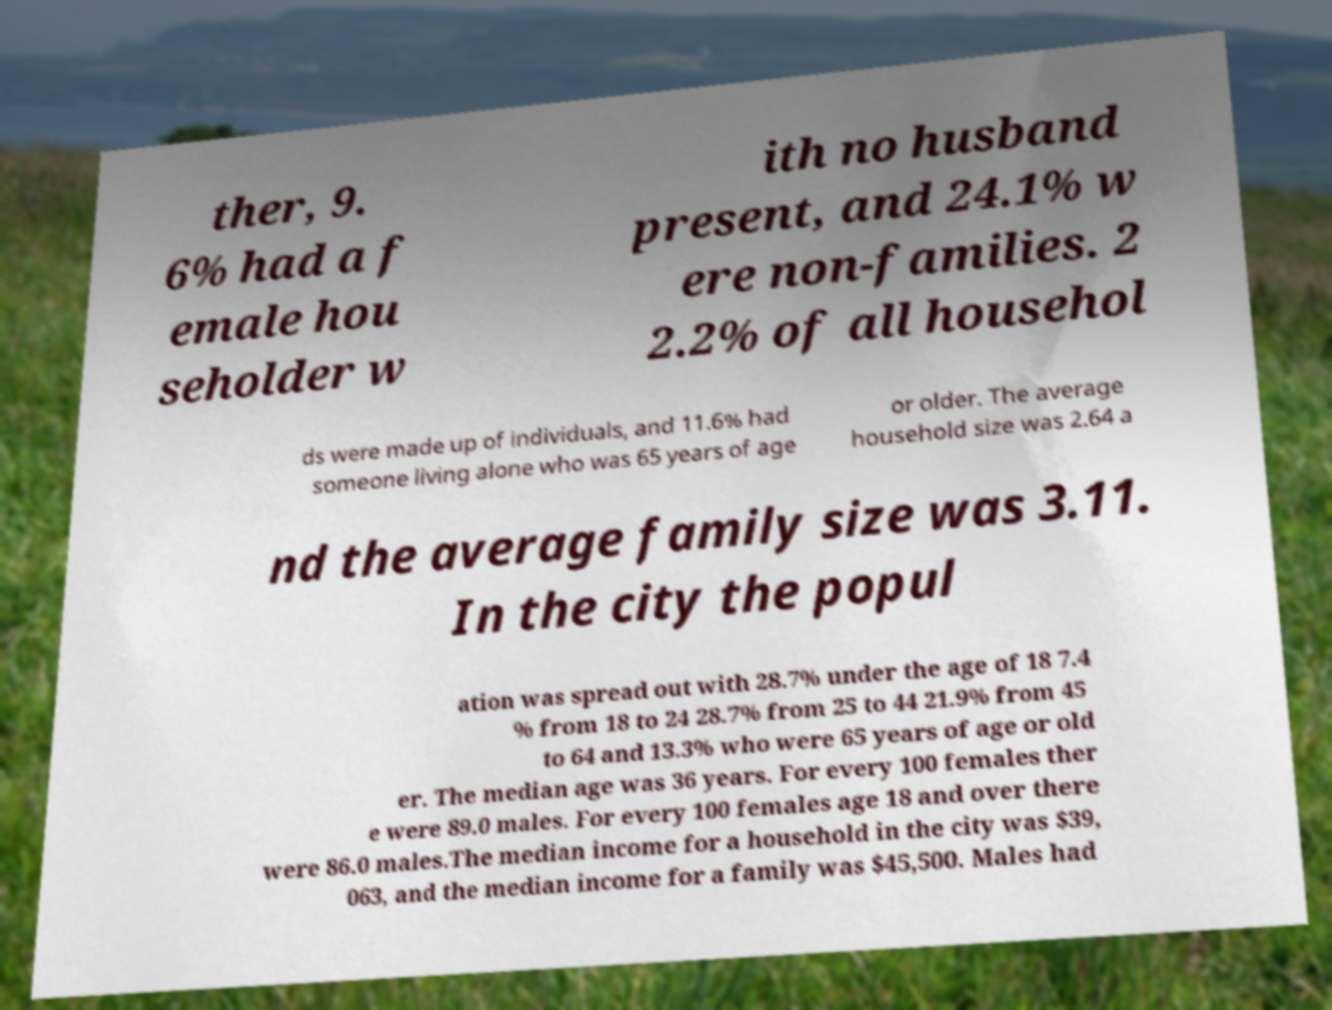I need the written content from this picture converted into text. Can you do that? ther, 9. 6% had a f emale hou seholder w ith no husband present, and 24.1% w ere non-families. 2 2.2% of all househol ds were made up of individuals, and 11.6% had someone living alone who was 65 years of age or older. The average household size was 2.64 a nd the average family size was 3.11. In the city the popul ation was spread out with 28.7% under the age of 18 7.4 % from 18 to 24 28.7% from 25 to 44 21.9% from 45 to 64 and 13.3% who were 65 years of age or old er. The median age was 36 years. For every 100 females ther e were 89.0 males. For every 100 females age 18 and over there were 86.0 males.The median income for a household in the city was $39, 063, and the median income for a family was $45,500. Males had 